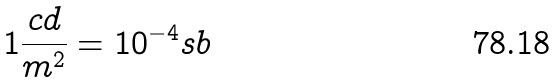<formula> <loc_0><loc_0><loc_500><loc_500>1 \frac { c d } { m ^ { 2 } } = 1 0 ^ { - 4 } s b</formula> 